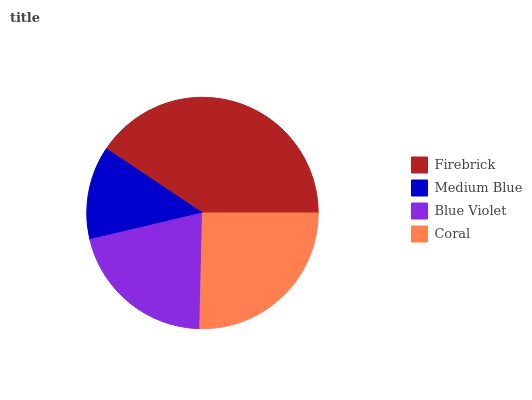Is Medium Blue the minimum?
Answer yes or no. Yes. Is Firebrick the maximum?
Answer yes or no. Yes. Is Blue Violet the minimum?
Answer yes or no. No. Is Blue Violet the maximum?
Answer yes or no. No. Is Blue Violet greater than Medium Blue?
Answer yes or no. Yes. Is Medium Blue less than Blue Violet?
Answer yes or no. Yes. Is Medium Blue greater than Blue Violet?
Answer yes or no. No. Is Blue Violet less than Medium Blue?
Answer yes or no. No. Is Coral the high median?
Answer yes or no. Yes. Is Blue Violet the low median?
Answer yes or no. Yes. Is Firebrick the high median?
Answer yes or no. No. Is Medium Blue the low median?
Answer yes or no. No. 